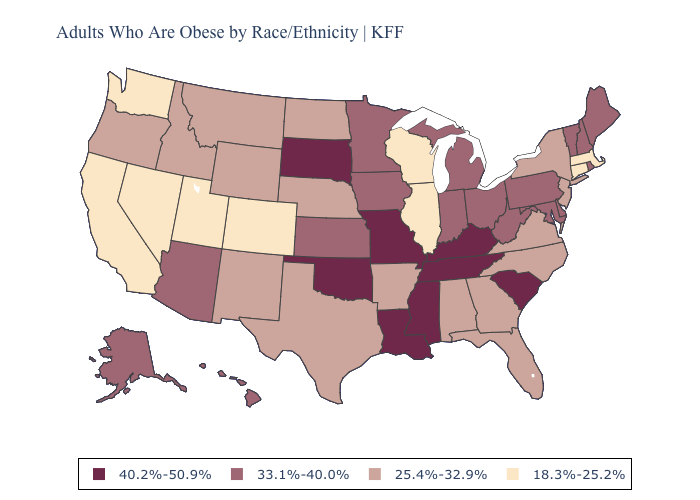Is the legend a continuous bar?
Answer briefly. No. What is the highest value in the MidWest ?
Quick response, please. 40.2%-50.9%. What is the value of Colorado?
Quick response, please. 18.3%-25.2%. What is the highest value in the MidWest ?
Concise answer only. 40.2%-50.9%. What is the lowest value in the Northeast?
Short answer required. 18.3%-25.2%. Is the legend a continuous bar?
Write a very short answer. No. What is the value of Arizona?
Write a very short answer. 33.1%-40.0%. Does Montana have the highest value in the West?
Be succinct. No. Which states have the lowest value in the USA?
Be succinct. California, Colorado, Connecticut, Illinois, Massachusetts, Nevada, Utah, Washington, Wisconsin. Does Maryland have a lower value than Kansas?
Give a very brief answer. No. What is the value of Pennsylvania?
Give a very brief answer. 33.1%-40.0%. What is the value of Iowa?
Be succinct. 33.1%-40.0%. What is the highest value in the USA?
Keep it brief. 40.2%-50.9%. Among the states that border Wyoming , does South Dakota have the highest value?
Keep it brief. Yes. Does Rhode Island have the highest value in the USA?
Answer briefly. No. 